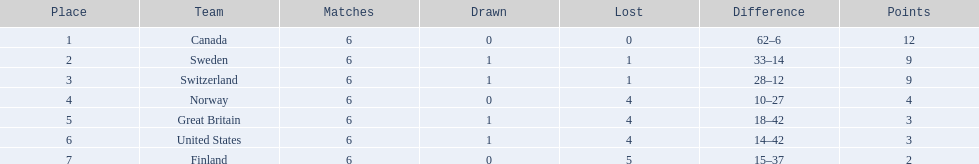Which are the two countries? Switzerland, Great Britain. What were the point totals for each of these countries? 9, 3. Of these point totals, which is better? 9. Which country earned this point total? Switzerland. 